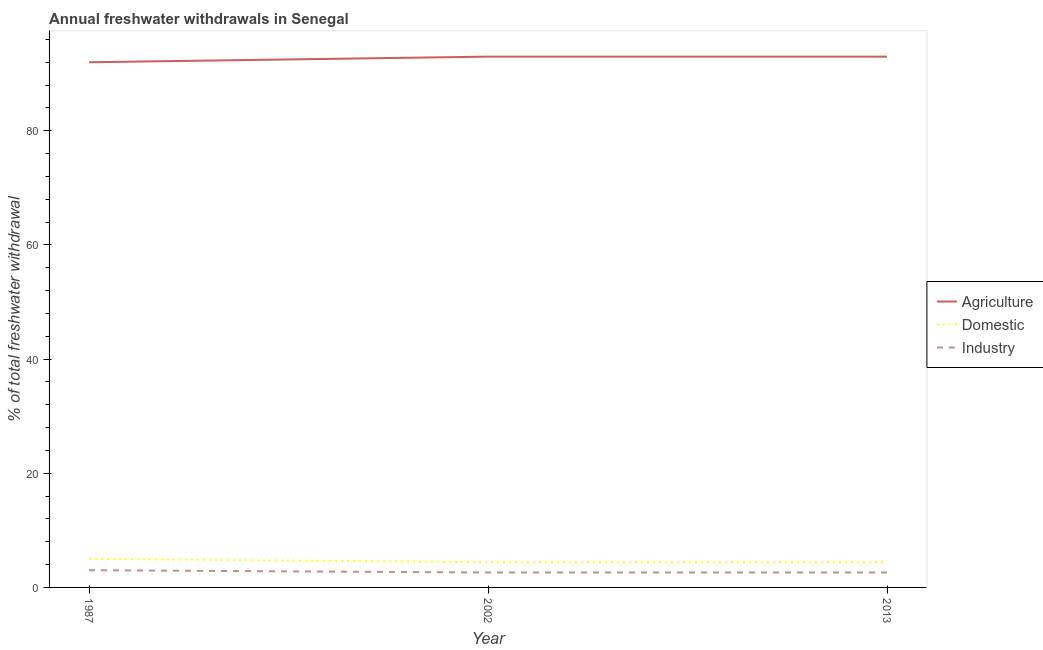What is the percentage of freshwater withdrawal for industry in 2013?
Your answer should be very brief. 2.61. Across all years, what is the maximum percentage of freshwater withdrawal for agriculture?
Make the answer very short. 92.98. Across all years, what is the minimum percentage of freshwater withdrawal for agriculture?
Your response must be concise. 91.99. In which year was the percentage of freshwater withdrawal for agriculture maximum?
Offer a terse response. 2002. In which year was the percentage of freshwater withdrawal for domestic purposes minimum?
Your answer should be compact. 2002. What is the total percentage of freshwater withdrawal for agriculture in the graph?
Offer a very short reply. 277.95. What is the difference between the percentage of freshwater withdrawal for agriculture in 1987 and that in 2002?
Give a very brief answer. -0.99. What is the difference between the percentage of freshwater withdrawal for agriculture in 1987 and the percentage of freshwater withdrawal for industry in 2002?
Offer a very short reply. 89.38. What is the average percentage of freshwater withdrawal for agriculture per year?
Make the answer very short. 92.65. In the year 2013, what is the difference between the percentage of freshwater withdrawal for industry and percentage of freshwater withdrawal for domestic purposes?
Give a very brief answer. -1.8. What is the ratio of the percentage of freshwater withdrawal for domestic purposes in 1987 to that in 2013?
Your answer should be very brief. 1.13. Is the difference between the percentage of freshwater withdrawal for agriculture in 1987 and 2013 greater than the difference between the percentage of freshwater withdrawal for industry in 1987 and 2013?
Provide a succinct answer. No. What is the difference between the highest and the second highest percentage of freshwater withdrawal for domestic purposes?
Provide a succinct answer. 0.59. What is the difference between the highest and the lowest percentage of freshwater withdrawal for industry?
Your answer should be very brief. 0.4. Is the sum of the percentage of freshwater withdrawal for domestic purposes in 1987 and 2002 greater than the maximum percentage of freshwater withdrawal for agriculture across all years?
Provide a short and direct response. No. Is it the case that in every year, the sum of the percentage of freshwater withdrawal for agriculture and percentage of freshwater withdrawal for domestic purposes is greater than the percentage of freshwater withdrawal for industry?
Your answer should be compact. Yes. Does the percentage of freshwater withdrawal for domestic purposes monotonically increase over the years?
Keep it short and to the point. No. What is the difference between two consecutive major ticks on the Y-axis?
Make the answer very short. 20. Where does the legend appear in the graph?
Your answer should be compact. Center right. How are the legend labels stacked?
Your answer should be compact. Vertical. What is the title of the graph?
Give a very brief answer. Annual freshwater withdrawals in Senegal. What is the label or title of the Y-axis?
Your answer should be compact. % of total freshwater withdrawal. What is the % of total freshwater withdrawal in Agriculture in 1987?
Provide a succinct answer. 91.99. What is the % of total freshwater withdrawal of Industry in 1987?
Give a very brief answer. 3.02. What is the % of total freshwater withdrawal in Agriculture in 2002?
Keep it short and to the point. 92.98. What is the % of total freshwater withdrawal in Domestic in 2002?
Your response must be concise. 4.41. What is the % of total freshwater withdrawal in Industry in 2002?
Ensure brevity in your answer.  2.61. What is the % of total freshwater withdrawal of Agriculture in 2013?
Provide a short and direct response. 92.98. What is the % of total freshwater withdrawal of Domestic in 2013?
Give a very brief answer. 4.41. What is the % of total freshwater withdrawal of Industry in 2013?
Your response must be concise. 2.61. Across all years, what is the maximum % of total freshwater withdrawal in Agriculture?
Provide a succinct answer. 92.98. Across all years, what is the maximum % of total freshwater withdrawal of Domestic?
Your answer should be very brief. 5. Across all years, what is the maximum % of total freshwater withdrawal in Industry?
Give a very brief answer. 3.02. Across all years, what is the minimum % of total freshwater withdrawal of Agriculture?
Your response must be concise. 91.99. Across all years, what is the minimum % of total freshwater withdrawal of Domestic?
Provide a short and direct response. 4.41. Across all years, what is the minimum % of total freshwater withdrawal of Industry?
Make the answer very short. 2.61. What is the total % of total freshwater withdrawal of Agriculture in the graph?
Your response must be concise. 277.95. What is the total % of total freshwater withdrawal of Domestic in the graph?
Offer a very short reply. 13.82. What is the total % of total freshwater withdrawal in Industry in the graph?
Keep it short and to the point. 8.24. What is the difference between the % of total freshwater withdrawal in Agriculture in 1987 and that in 2002?
Offer a very short reply. -0.99. What is the difference between the % of total freshwater withdrawal in Domestic in 1987 and that in 2002?
Your answer should be compact. 0.59. What is the difference between the % of total freshwater withdrawal in Industry in 1987 and that in 2002?
Your answer should be very brief. 0.4. What is the difference between the % of total freshwater withdrawal in Agriculture in 1987 and that in 2013?
Make the answer very short. -0.99. What is the difference between the % of total freshwater withdrawal of Domestic in 1987 and that in 2013?
Your answer should be very brief. 0.59. What is the difference between the % of total freshwater withdrawal in Industry in 1987 and that in 2013?
Make the answer very short. 0.4. What is the difference between the % of total freshwater withdrawal of Agriculture in 2002 and that in 2013?
Provide a succinct answer. 0. What is the difference between the % of total freshwater withdrawal of Industry in 2002 and that in 2013?
Your answer should be very brief. 0. What is the difference between the % of total freshwater withdrawal in Agriculture in 1987 and the % of total freshwater withdrawal in Domestic in 2002?
Ensure brevity in your answer.  87.58. What is the difference between the % of total freshwater withdrawal of Agriculture in 1987 and the % of total freshwater withdrawal of Industry in 2002?
Give a very brief answer. 89.38. What is the difference between the % of total freshwater withdrawal in Domestic in 1987 and the % of total freshwater withdrawal in Industry in 2002?
Ensure brevity in your answer.  2.39. What is the difference between the % of total freshwater withdrawal of Agriculture in 1987 and the % of total freshwater withdrawal of Domestic in 2013?
Provide a short and direct response. 87.58. What is the difference between the % of total freshwater withdrawal in Agriculture in 1987 and the % of total freshwater withdrawal in Industry in 2013?
Keep it short and to the point. 89.38. What is the difference between the % of total freshwater withdrawal in Domestic in 1987 and the % of total freshwater withdrawal in Industry in 2013?
Offer a terse response. 2.39. What is the difference between the % of total freshwater withdrawal of Agriculture in 2002 and the % of total freshwater withdrawal of Domestic in 2013?
Give a very brief answer. 88.57. What is the difference between the % of total freshwater withdrawal of Agriculture in 2002 and the % of total freshwater withdrawal of Industry in 2013?
Keep it short and to the point. 90.37. What is the difference between the % of total freshwater withdrawal in Domestic in 2002 and the % of total freshwater withdrawal in Industry in 2013?
Your response must be concise. 1.8. What is the average % of total freshwater withdrawal of Agriculture per year?
Ensure brevity in your answer.  92.65. What is the average % of total freshwater withdrawal in Domestic per year?
Make the answer very short. 4.61. What is the average % of total freshwater withdrawal of Industry per year?
Offer a very short reply. 2.75. In the year 1987, what is the difference between the % of total freshwater withdrawal in Agriculture and % of total freshwater withdrawal in Domestic?
Your answer should be compact. 86.99. In the year 1987, what is the difference between the % of total freshwater withdrawal of Agriculture and % of total freshwater withdrawal of Industry?
Make the answer very short. 88.97. In the year 1987, what is the difference between the % of total freshwater withdrawal of Domestic and % of total freshwater withdrawal of Industry?
Your response must be concise. 1.99. In the year 2002, what is the difference between the % of total freshwater withdrawal in Agriculture and % of total freshwater withdrawal in Domestic?
Your response must be concise. 88.57. In the year 2002, what is the difference between the % of total freshwater withdrawal of Agriculture and % of total freshwater withdrawal of Industry?
Ensure brevity in your answer.  90.37. In the year 2002, what is the difference between the % of total freshwater withdrawal in Domestic and % of total freshwater withdrawal in Industry?
Offer a terse response. 1.8. In the year 2013, what is the difference between the % of total freshwater withdrawal in Agriculture and % of total freshwater withdrawal in Domestic?
Provide a short and direct response. 88.57. In the year 2013, what is the difference between the % of total freshwater withdrawal in Agriculture and % of total freshwater withdrawal in Industry?
Make the answer very short. 90.37. In the year 2013, what is the difference between the % of total freshwater withdrawal of Domestic and % of total freshwater withdrawal of Industry?
Provide a short and direct response. 1.8. What is the ratio of the % of total freshwater withdrawal of Domestic in 1987 to that in 2002?
Make the answer very short. 1.13. What is the ratio of the % of total freshwater withdrawal of Industry in 1987 to that in 2002?
Provide a succinct answer. 1.15. What is the ratio of the % of total freshwater withdrawal in Domestic in 1987 to that in 2013?
Offer a very short reply. 1.13. What is the ratio of the % of total freshwater withdrawal in Industry in 1987 to that in 2013?
Provide a short and direct response. 1.15. What is the ratio of the % of total freshwater withdrawal of Domestic in 2002 to that in 2013?
Keep it short and to the point. 1. What is the difference between the highest and the second highest % of total freshwater withdrawal in Domestic?
Your answer should be very brief. 0.59. What is the difference between the highest and the second highest % of total freshwater withdrawal of Industry?
Make the answer very short. 0.4. What is the difference between the highest and the lowest % of total freshwater withdrawal in Agriculture?
Provide a short and direct response. 0.99. What is the difference between the highest and the lowest % of total freshwater withdrawal in Domestic?
Make the answer very short. 0.59. What is the difference between the highest and the lowest % of total freshwater withdrawal of Industry?
Your answer should be very brief. 0.4. 